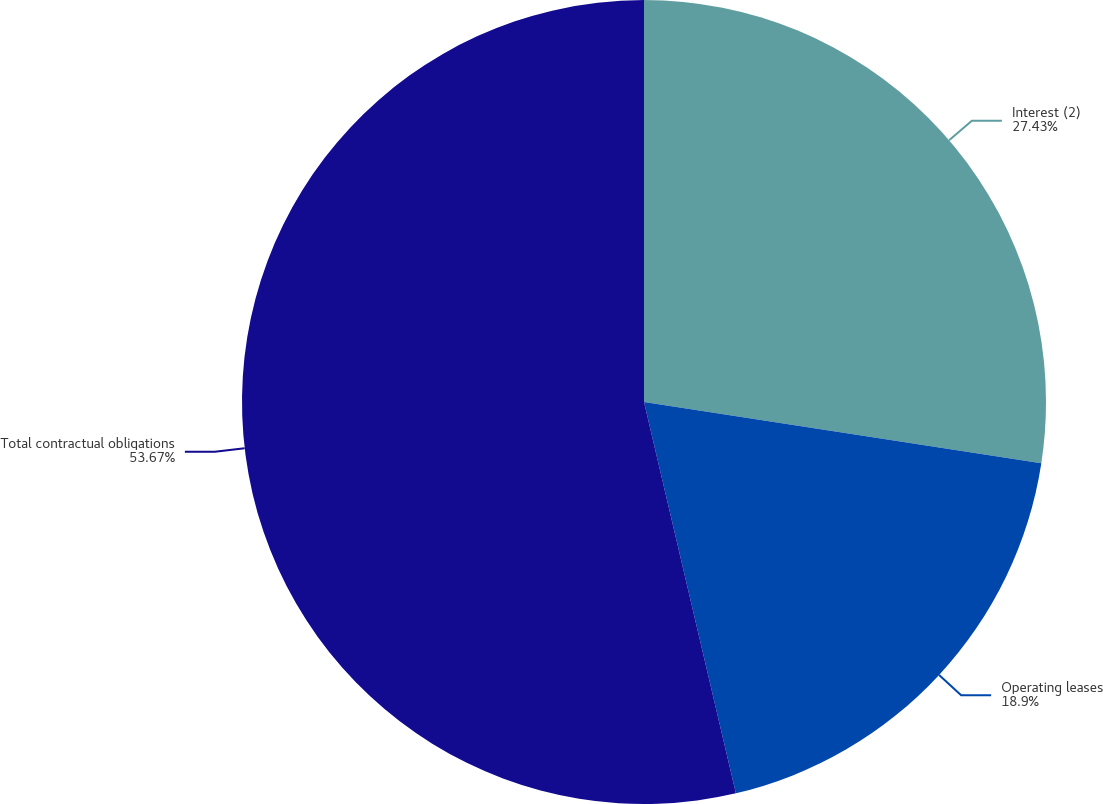Convert chart to OTSL. <chart><loc_0><loc_0><loc_500><loc_500><pie_chart><fcel>Interest (2)<fcel>Operating leases<fcel>Total contractual obligations<nl><fcel>27.43%<fcel>18.9%<fcel>53.67%<nl></chart> 